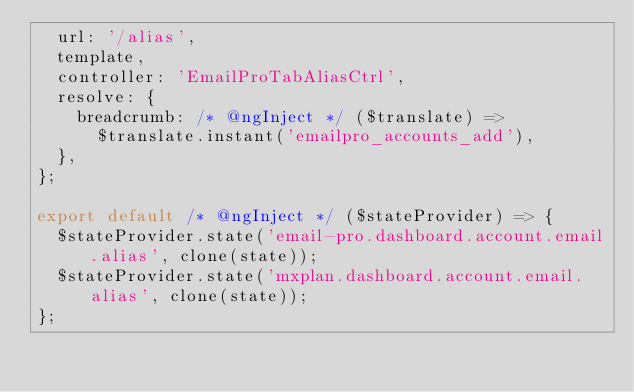Convert code to text. <code><loc_0><loc_0><loc_500><loc_500><_JavaScript_>  url: '/alias',
  template,
  controller: 'EmailProTabAliasCtrl',
  resolve: {
    breadcrumb: /* @ngInject */ ($translate) =>
      $translate.instant('emailpro_accounts_add'),
  },
};

export default /* @ngInject */ ($stateProvider) => {
  $stateProvider.state('email-pro.dashboard.account.email.alias', clone(state));
  $stateProvider.state('mxplan.dashboard.account.email.alias', clone(state));
};
</code> 